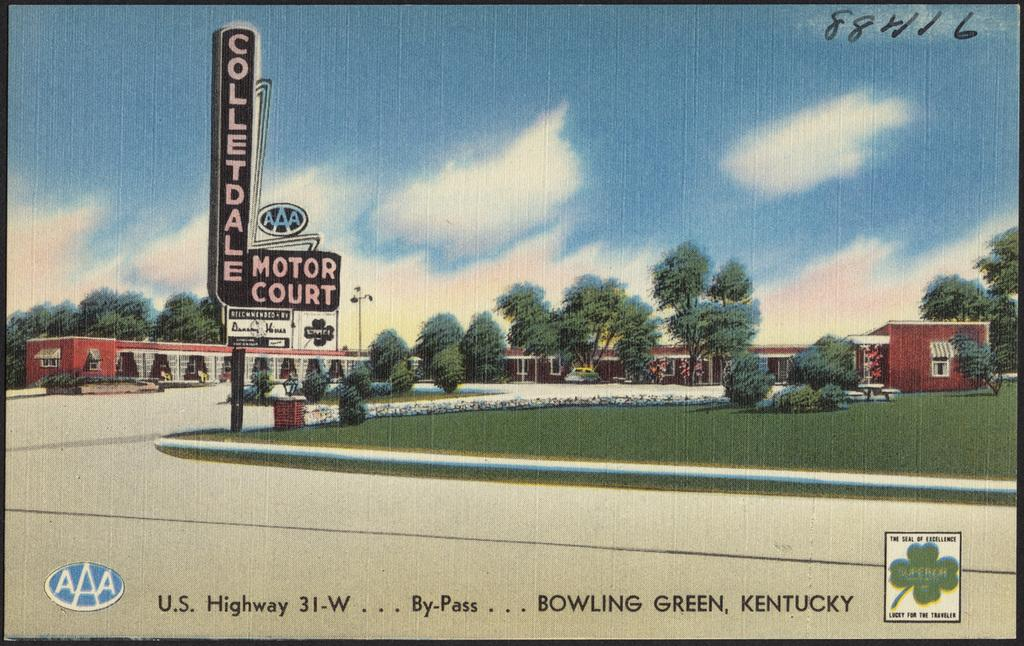<image>
Give a short and clear explanation of the subsequent image. A postcard showing a AAA motel in Bowling Green Kentucky. 